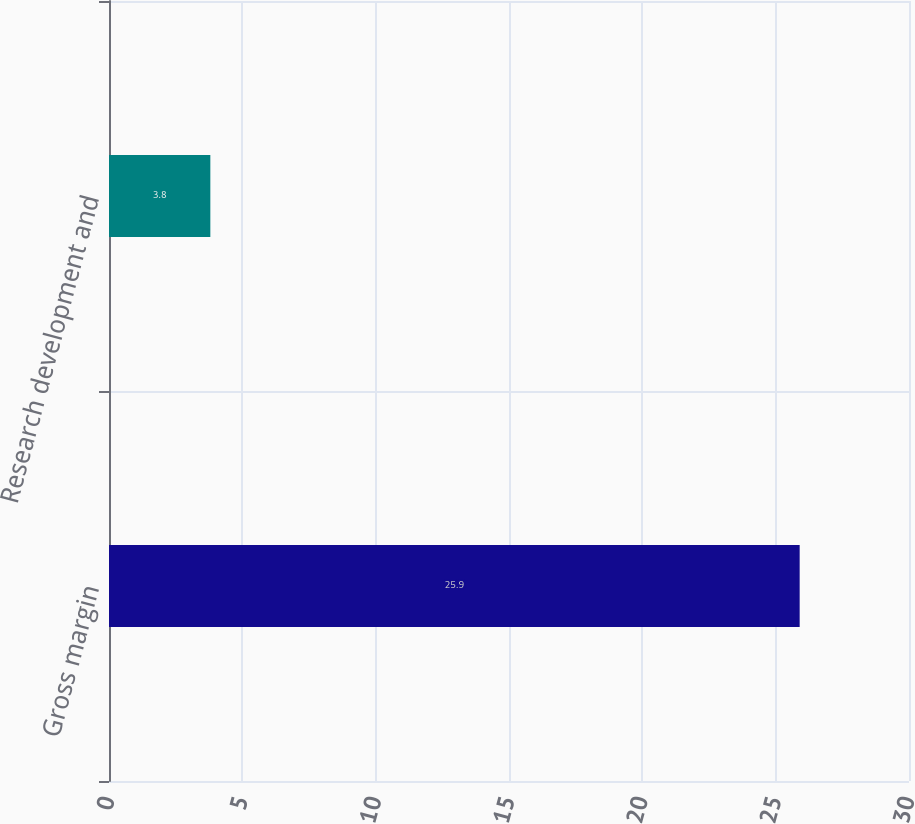Convert chart to OTSL. <chart><loc_0><loc_0><loc_500><loc_500><bar_chart><fcel>Gross margin<fcel>Research development and<nl><fcel>25.9<fcel>3.8<nl></chart> 